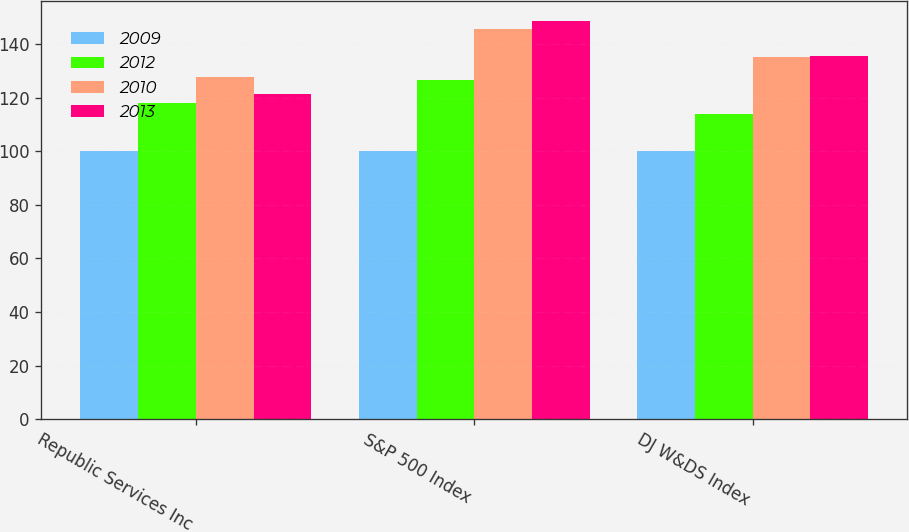<chart> <loc_0><loc_0><loc_500><loc_500><stacked_bar_chart><ecel><fcel>Republic Services Inc<fcel>S&P 500 Index<fcel>DJ W&DS Index<nl><fcel>2009<fcel>100<fcel>100<fcel>100<nl><fcel>2012<fcel>118<fcel>126.46<fcel>113.83<nl><fcel>2010<fcel>127.75<fcel>145.51<fcel>135.21<nl><fcel>2013<fcel>121.32<fcel>148.59<fcel>135.45<nl></chart> 